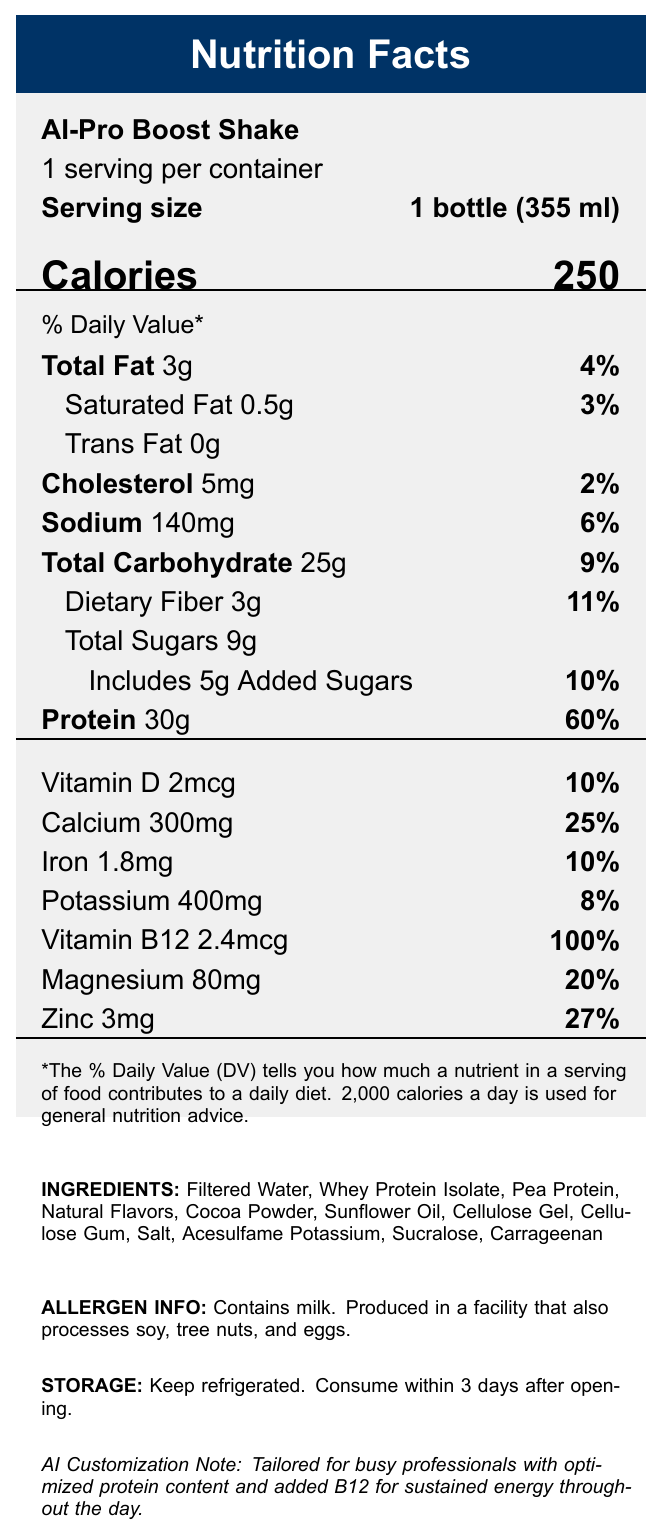what is the serving size for AI-Pro Boost Shake? The serving size is clearly mentioned under "Serving size" in the upper section of the document.
Answer: 1 bottle (355 ml) how many calories are in one serving of the AI-Pro Boost Shake? The number of calories is highlighted under "Calories" in large font in the document.
Answer: 250 calories what percentage of the Daily Value is the protein content in one serving? Under "Protein," the document states that 30g of protein provides 60% of the Daily Value.
Answer: 60% does the AI-Pro Boost Shake contain any trans fat? The document explicitly states "Trans Fat 0g" under the fat content section.
Answer: No how much dietary fiber is in one serving of the shake? The "Total Carbohydrate" section lists 3g of dietary fiber and also indicates this is 11% of the Daily Value.
Answer: 3g which vitamin has the highest percentage Daily Value in one serving of the AI-Pro Boost Shake? A. Vitamin D B. Calcium C. Iron D. Vitamin B12 The document shows that Vitamin B12 has a 100% Daily Value, the highest percentage among all listed vitamins and minerals.
Answer: D. Vitamin B12 how much iron is in one serving of the shake? A. 1.8mg B. 2.4mg C. 300mg D. 400mg According to the "Iron" section, one serving of the shake contains 1.8mg of iron.
Answer: A. 1.8mg is there any cholesterol in the AI-Pro Boost Shake? Under the "Cholesterol" section, it states there are 5mg of cholesterol per serving.
Answer: Yes describe the main idea of the document. The document lists the nutrient values per serving, gives additional details on ingredients and allergens, as well as storage instructions, all tailored for busy professionals seeking a nutritional boost.
Answer: The document provides detailed nutrition information for the AI-Pro Boost Shake, including serving size, calories, fat content, protein, vitamins, and minerals. The shake is designed for busy professionals with an optimized protein content and additional Vitamin B12 for sustained energy. what are the primary sources of protein in the shake? Under "INGREDIENTS," the document lists Whey Protein Isolate and Pea Protein as the primary sources of protein.
Answer: Whey Protein Isolate and Pea Protein how much added sugar is included in one serving? The document indicates that there are 5g of added sugars, which is 10% of the Daily Value.
Answer: 5g what is the storage instruction for the AI-Pro Boost Shake? The storage instructions at the bottom of the document state to keep the shake refrigerated and consume it within 3 days after opening.
Answer: Keep refrigerated. Consume within 3 days after opening. what allergens are mentioned on the label? The "ALLERGEN INFO" section provides this information.
Answer: Contains milk. Produced in a facility that also processes soy, tree nuts, and eggs. does the document provide any information on the production date of the AI-Pro Boost Shake? The document does not include any information regarding the production date.
Answer: Cannot be determined what is the main customization note provided for this AI-recommended shake? The "AI Customization Note" at the bottom of the document provides this specific customization information for the shake.
Answer: Tailored for busy professionals with optimized protein content and added B12 for sustained energy throughout the day. 